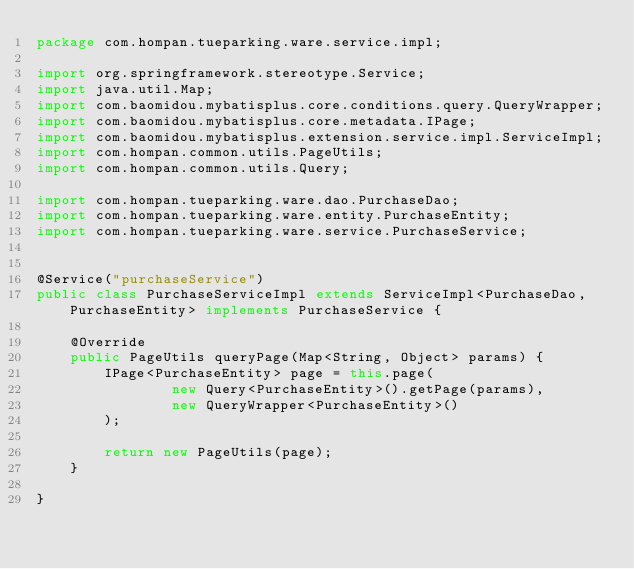<code> <loc_0><loc_0><loc_500><loc_500><_Java_>package com.hompan.tueparking.ware.service.impl;

import org.springframework.stereotype.Service;
import java.util.Map;
import com.baomidou.mybatisplus.core.conditions.query.QueryWrapper;
import com.baomidou.mybatisplus.core.metadata.IPage;
import com.baomidou.mybatisplus.extension.service.impl.ServiceImpl;
import com.hompan.common.utils.PageUtils;
import com.hompan.common.utils.Query;

import com.hompan.tueparking.ware.dao.PurchaseDao;
import com.hompan.tueparking.ware.entity.PurchaseEntity;
import com.hompan.tueparking.ware.service.PurchaseService;


@Service("purchaseService")
public class PurchaseServiceImpl extends ServiceImpl<PurchaseDao, PurchaseEntity> implements PurchaseService {

    @Override
    public PageUtils queryPage(Map<String, Object> params) {
        IPage<PurchaseEntity> page = this.page(
                new Query<PurchaseEntity>().getPage(params),
                new QueryWrapper<PurchaseEntity>()
        );

        return new PageUtils(page);
    }

}</code> 